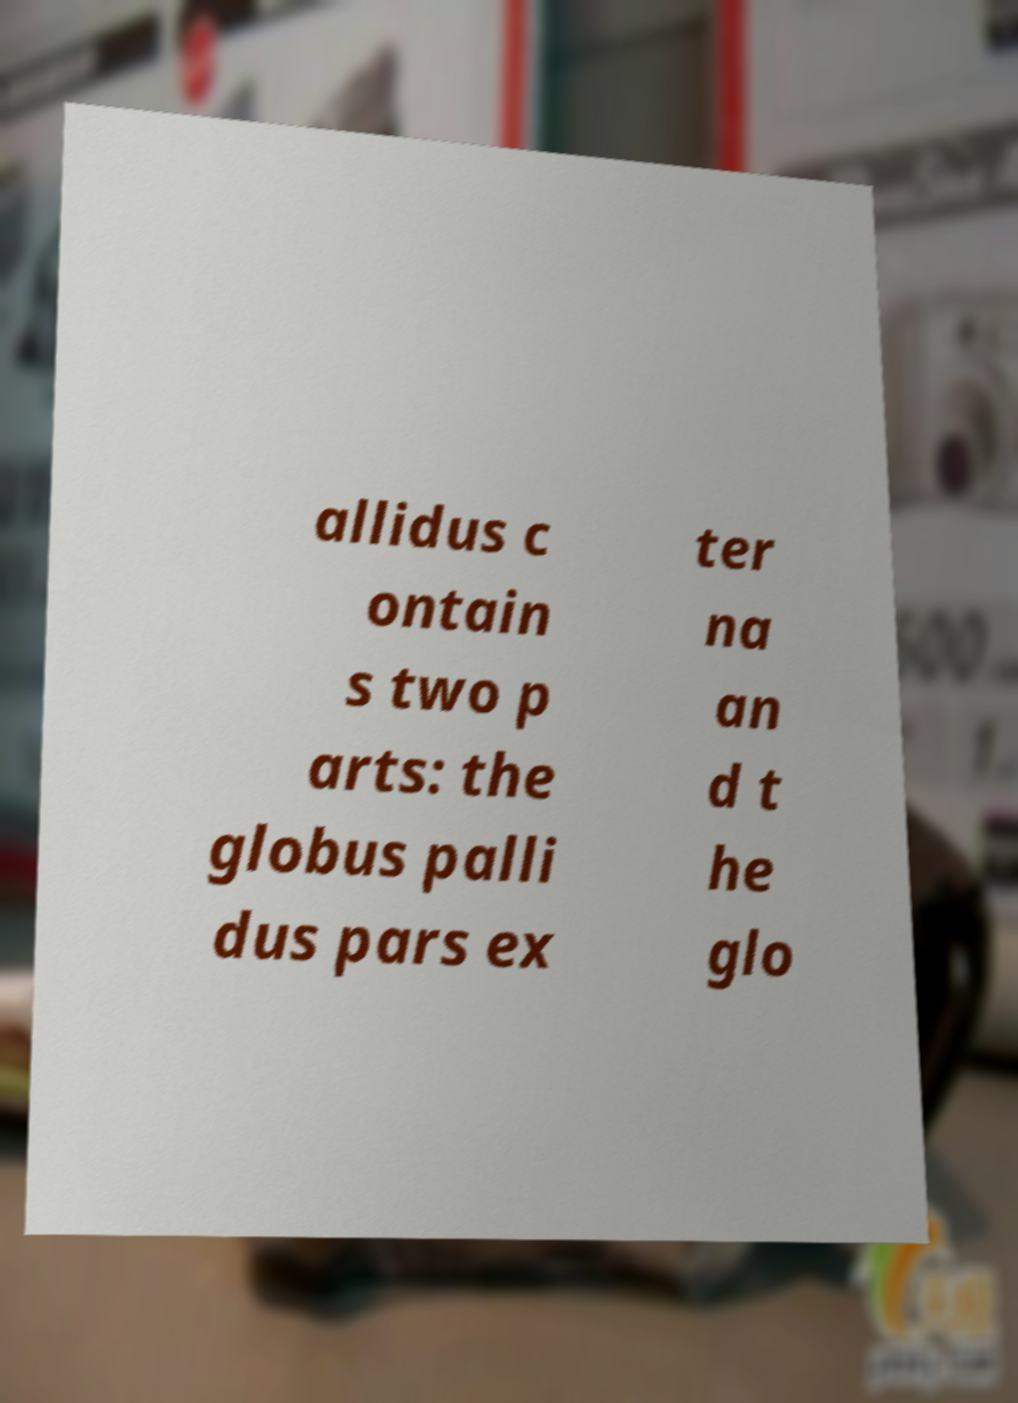For documentation purposes, I need the text within this image transcribed. Could you provide that? allidus c ontain s two p arts: the globus palli dus pars ex ter na an d t he glo 